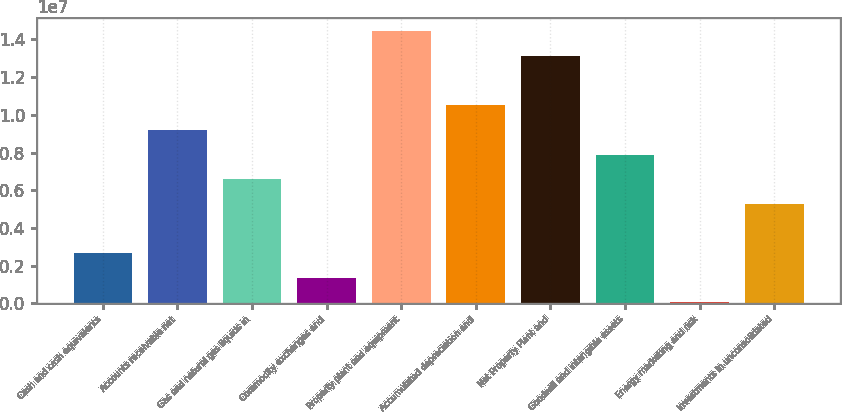<chart> <loc_0><loc_0><loc_500><loc_500><bar_chart><fcel>Cash and cash equivalents<fcel>Accounts receivable net<fcel>Gas and natural gas liquids in<fcel>Commodity exchanges and<fcel>Property plant and equipment<fcel>Accumulated depreciation and<fcel>Net Property Plant and<fcel>Goodwill and intangible assets<fcel>Energy marketing and risk<fcel>Investments in unconsolidated<nl><fcel>2.66193e+06<fcel>9.20201e+06<fcel>6.58598e+06<fcel>1.35392e+06<fcel>1.44341e+07<fcel>1.051e+07<fcel>1.31261e+07<fcel>7.894e+06<fcel>45900<fcel>5.27796e+06<nl></chart> 